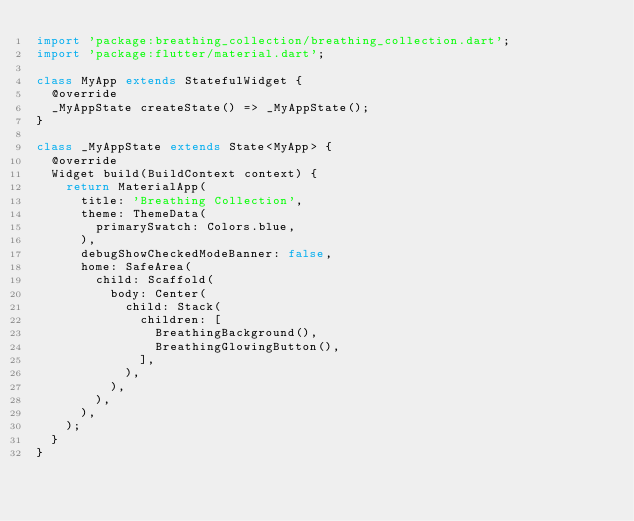<code> <loc_0><loc_0><loc_500><loc_500><_Dart_>import 'package:breathing_collection/breathing_collection.dart';
import 'package:flutter/material.dart';

class MyApp extends StatefulWidget {
  @override
  _MyAppState createState() => _MyAppState();
}

class _MyAppState extends State<MyApp> {
  @override
  Widget build(BuildContext context) {
    return MaterialApp(
      title: 'Breathing Collection',
      theme: ThemeData(
        primarySwatch: Colors.blue,
      ),
      debugShowCheckedModeBanner: false,
      home: SafeArea(
        child: Scaffold(
          body: Center(
            child: Stack(
              children: [
                BreathingBackground(),
                BreathingGlowingButton(),
              ],
            ),
          ),
        ),
      ),
    );
  }
}
</code> 